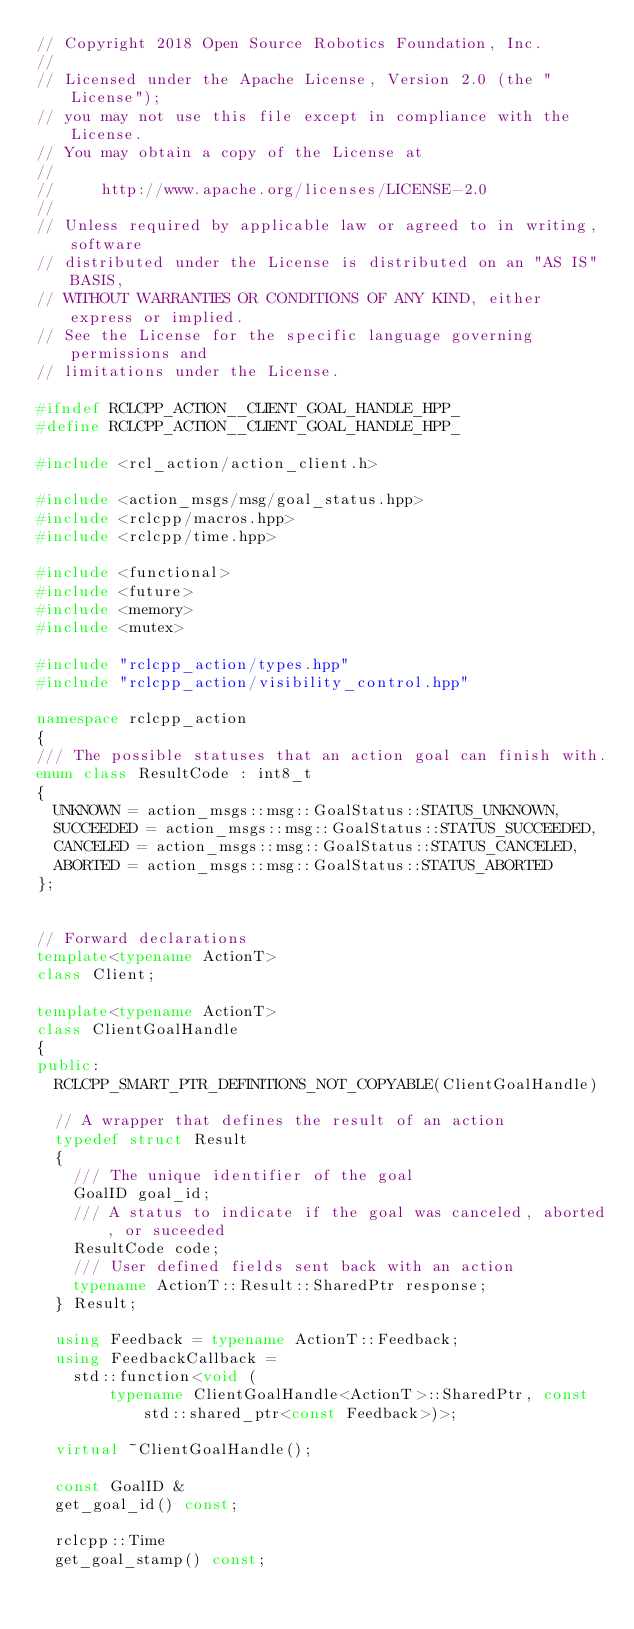Convert code to text. <code><loc_0><loc_0><loc_500><loc_500><_C++_>// Copyright 2018 Open Source Robotics Foundation, Inc.
//
// Licensed under the Apache License, Version 2.0 (the "License");
// you may not use this file except in compliance with the License.
// You may obtain a copy of the License at
//
//     http://www.apache.org/licenses/LICENSE-2.0
//
// Unless required by applicable law or agreed to in writing, software
// distributed under the License is distributed on an "AS IS" BASIS,
// WITHOUT WARRANTIES OR CONDITIONS OF ANY KIND, either express or implied.
// See the License for the specific language governing permissions and
// limitations under the License.

#ifndef RCLCPP_ACTION__CLIENT_GOAL_HANDLE_HPP_
#define RCLCPP_ACTION__CLIENT_GOAL_HANDLE_HPP_

#include <rcl_action/action_client.h>

#include <action_msgs/msg/goal_status.hpp>
#include <rclcpp/macros.hpp>
#include <rclcpp/time.hpp>

#include <functional>
#include <future>
#include <memory>
#include <mutex>

#include "rclcpp_action/types.hpp"
#include "rclcpp_action/visibility_control.hpp"

namespace rclcpp_action
{
/// The possible statuses that an action goal can finish with.
enum class ResultCode : int8_t
{
  UNKNOWN = action_msgs::msg::GoalStatus::STATUS_UNKNOWN,
  SUCCEEDED = action_msgs::msg::GoalStatus::STATUS_SUCCEEDED,
  CANCELED = action_msgs::msg::GoalStatus::STATUS_CANCELED,
  ABORTED = action_msgs::msg::GoalStatus::STATUS_ABORTED
};


// Forward declarations
template<typename ActionT>
class Client;

template<typename ActionT>
class ClientGoalHandle
{
public:
  RCLCPP_SMART_PTR_DEFINITIONS_NOT_COPYABLE(ClientGoalHandle)

  // A wrapper that defines the result of an action
  typedef struct Result
  {
    /// The unique identifier of the goal
    GoalID goal_id;
    /// A status to indicate if the goal was canceled, aborted, or suceeded
    ResultCode code;
    /// User defined fields sent back with an action
    typename ActionT::Result::SharedPtr response;
  } Result;

  using Feedback = typename ActionT::Feedback;
  using FeedbackCallback =
    std::function<void (
        typename ClientGoalHandle<ActionT>::SharedPtr, const std::shared_ptr<const Feedback>)>;

  virtual ~ClientGoalHandle();

  const GoalID &
  get_goal_id() const;

  rclcpp::Time
  get_goal_stamp() const;
</code> 